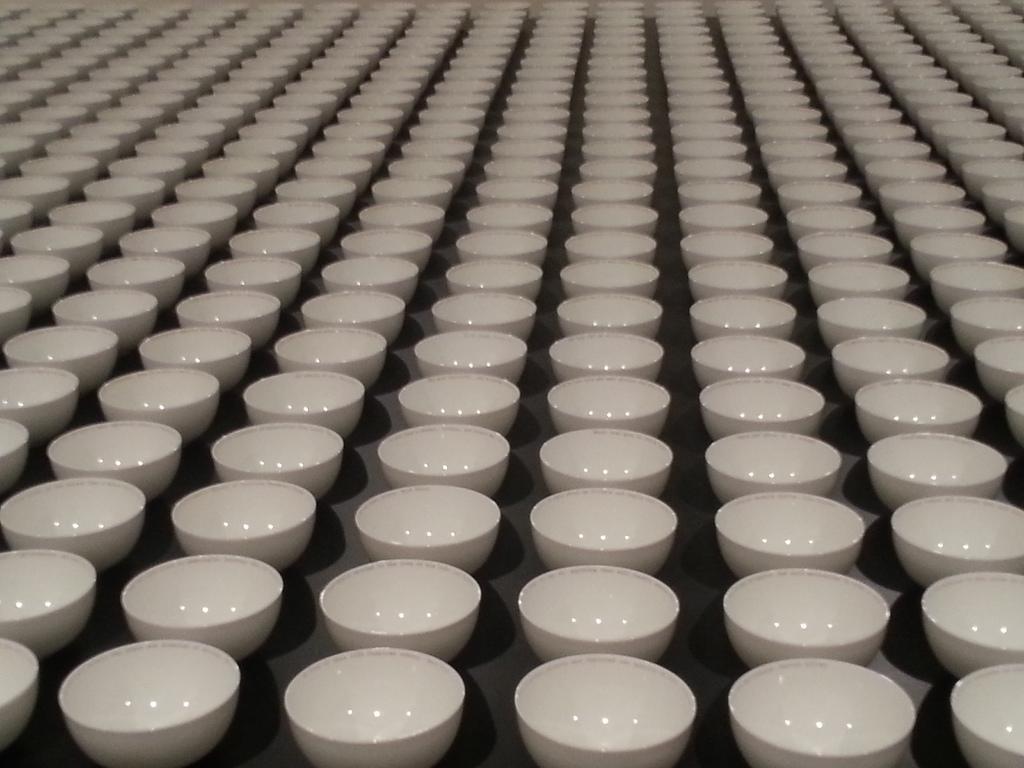In one or two sentences, can you explain what this image depicts? In this image I can see black colored surface and on it I can see number of bowls which are white in color. 